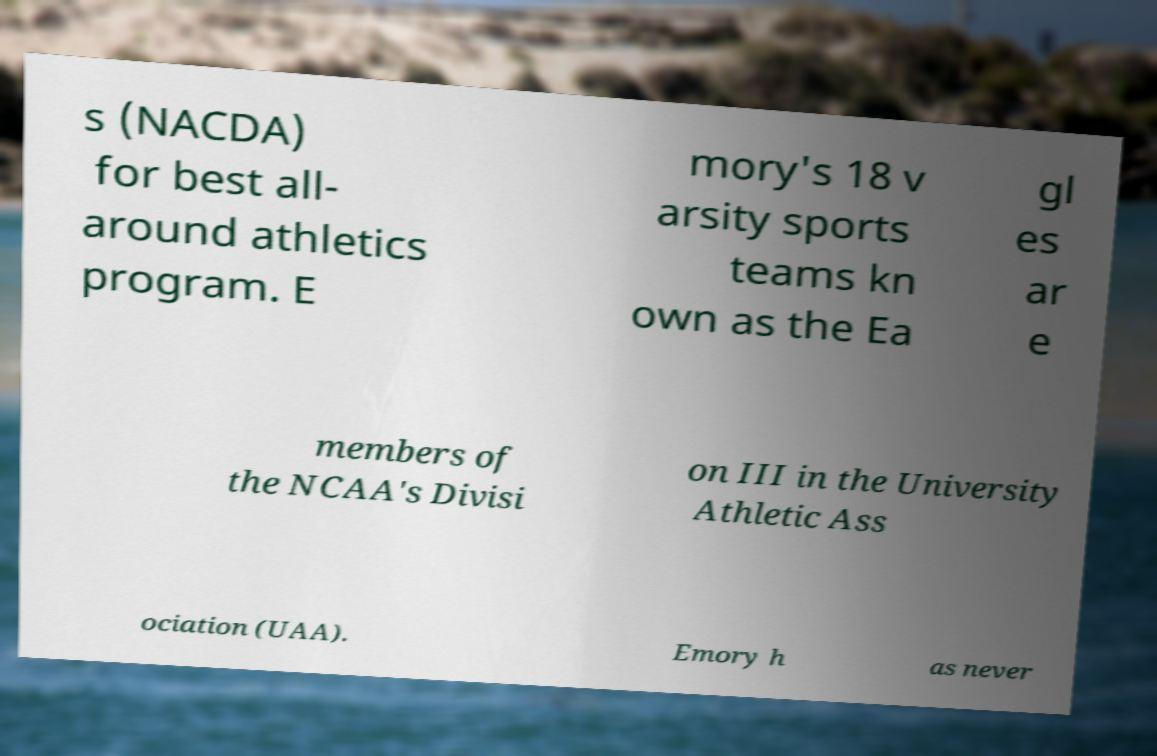What messages or text are displayed in this image? I need them in a readable, typed format. s (NACDA) for best all- around athletics program. E mory's 18 v arsity sports teams kn own as the Ea gl es ar e members of the NCAA's Divisi on III in the University Athletic Ass ociation (UAA). Emory h as never 